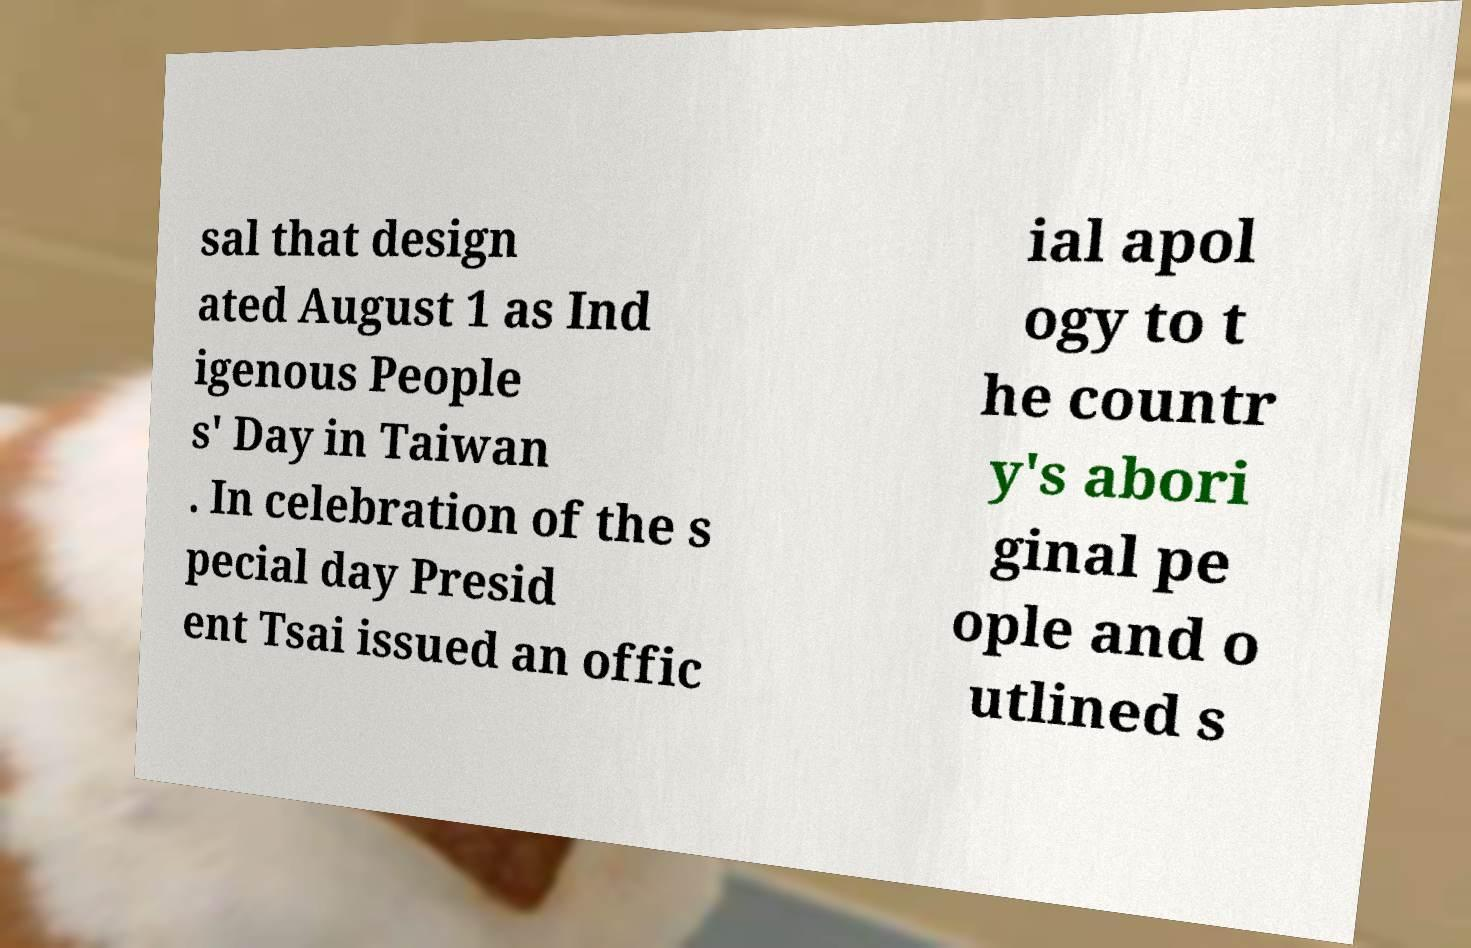What messages or text are displayed in this image? I need them in a readable, typed format. sal that design ated August 1 as Ind igenous People s' Day in Taiwan . In celebration of the s pecial day Presid ent Tsai issued an offic ial apol ogy to t he countr y's abori ginal pe ople and o utlined s 